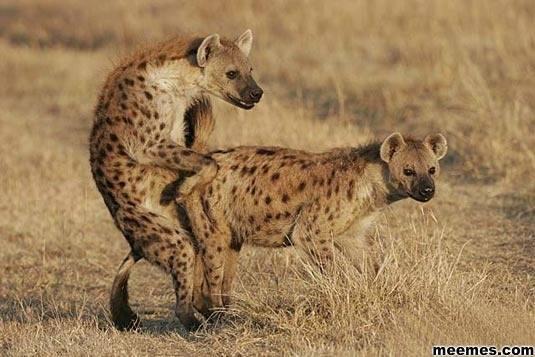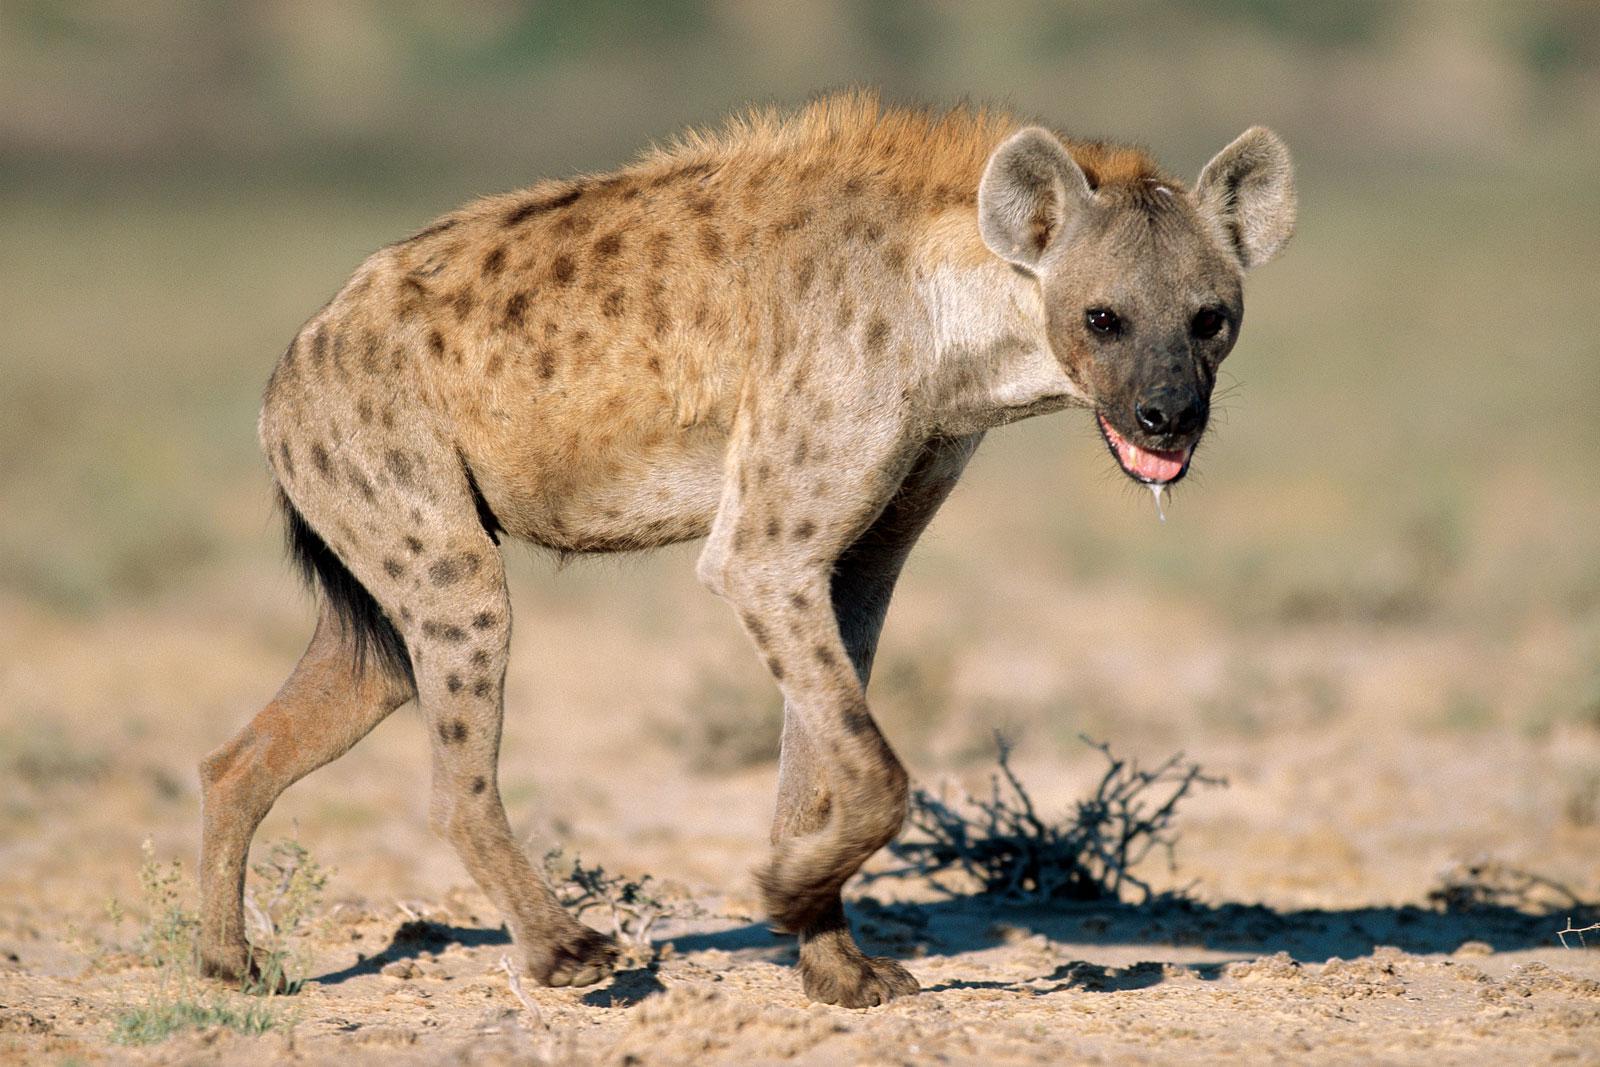The first image is the image on the left, the second image is the image on the right. Considering the images on both sides, is "One image contains at a least two hyenas." valid? Answer yes or no. Yes. 